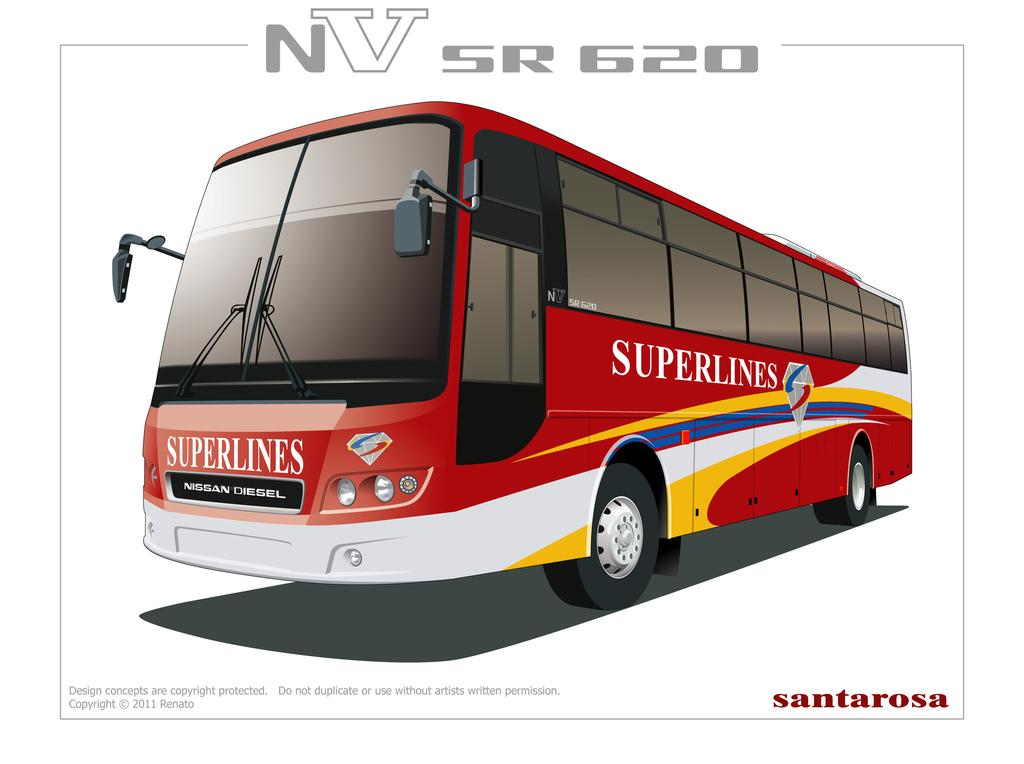What type of vehicle is in the image? There is a red color bus in the image. Can you describe any additional features of the bus? The bus has edited text in the image. What direction is the air blowing in the image? There is no mention of air or wind in the image, so it cannot be determined which direction the air is blowing. 